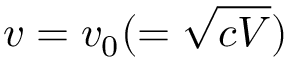<formula> <loc_0><loc_0><loc_500><loc_500>v = v _ { 0 } ( = \sqrt { c V } )</formula> 